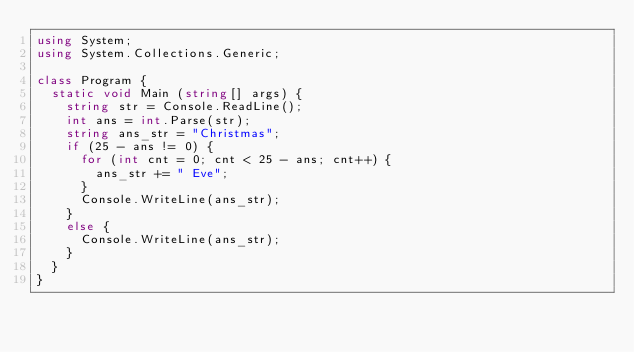<code> <loc_0><loc_0><loc_500><loc_500><_C#_>using System;
using System.Collections.Generic;

class Program {
  static void Main (string[] args) {
    string str = Console.ReadLine();
    int ans = int.Parse(str);
    string ans_str = "Christmas";
    if (25 - ans != 0) {
      for (int cnt = 0; cnt < 25 - ans; cnt++) {
        ans_str += " Eve";
      }
      Console.WriteLine(ans_str);
    }
    else {
      Console.WriteLine(ans_str);
    }
  }
}</code> 